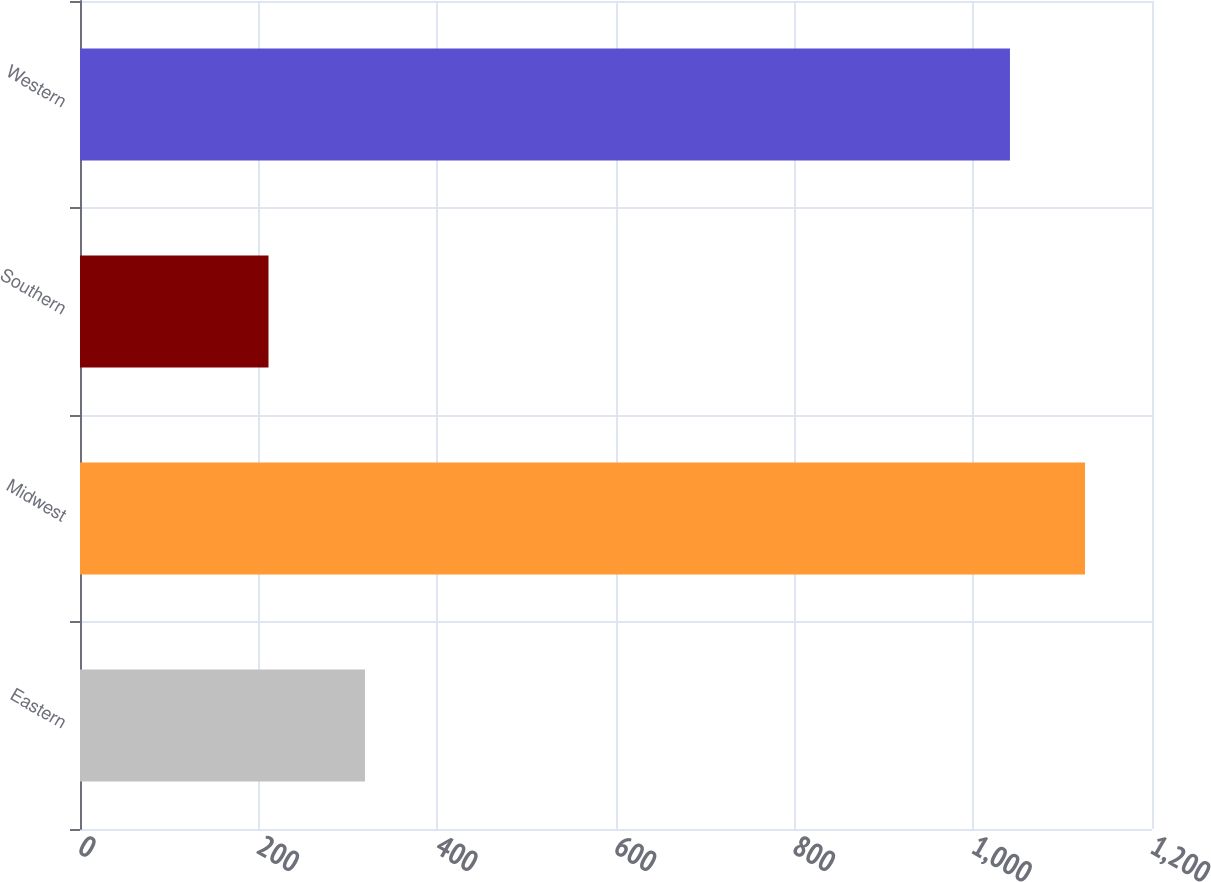Convert chart to OTSL. <chart><loc_0><loc_0><loc_500><loc_500><bar_chart><fcel>Eastern<fcel>Midwest<fcel>Southern<fcel>Western<nl><fcel>319<fcel>1125<fcel>211<fcel>1041<nl></chart> 